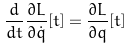<formula> <loc_0><loc_0><loc_500><loc_500>\frac { d } { d t } \frac { \partial L } { \partial \dot { q } } [ t ] = \frac { \partial L } { \partial q } [ t ]</formula> 